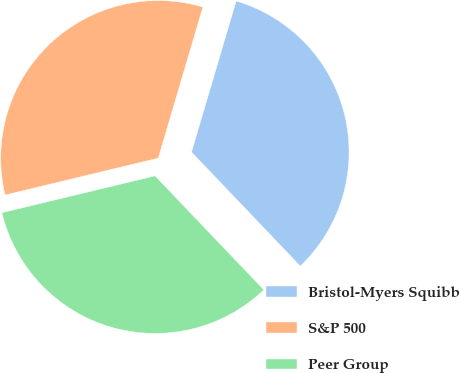<chart> <loc_0><loc_0><loc_500><loc_500><pie_chart><fcel>Bristol-Myers Squibb<fcel>S&P 500<fcel>Peer Group<nl><fcel>33.3%<fcel>33.33%<fcel>33.37%<nl></chart> 